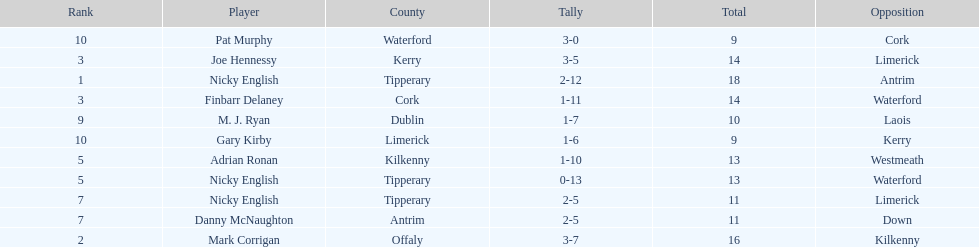Who ranked above mark corrigan? Nicky English. 